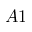<formula> <loc_0><loc_0><loc_500><loc_500>A 1</formula> 